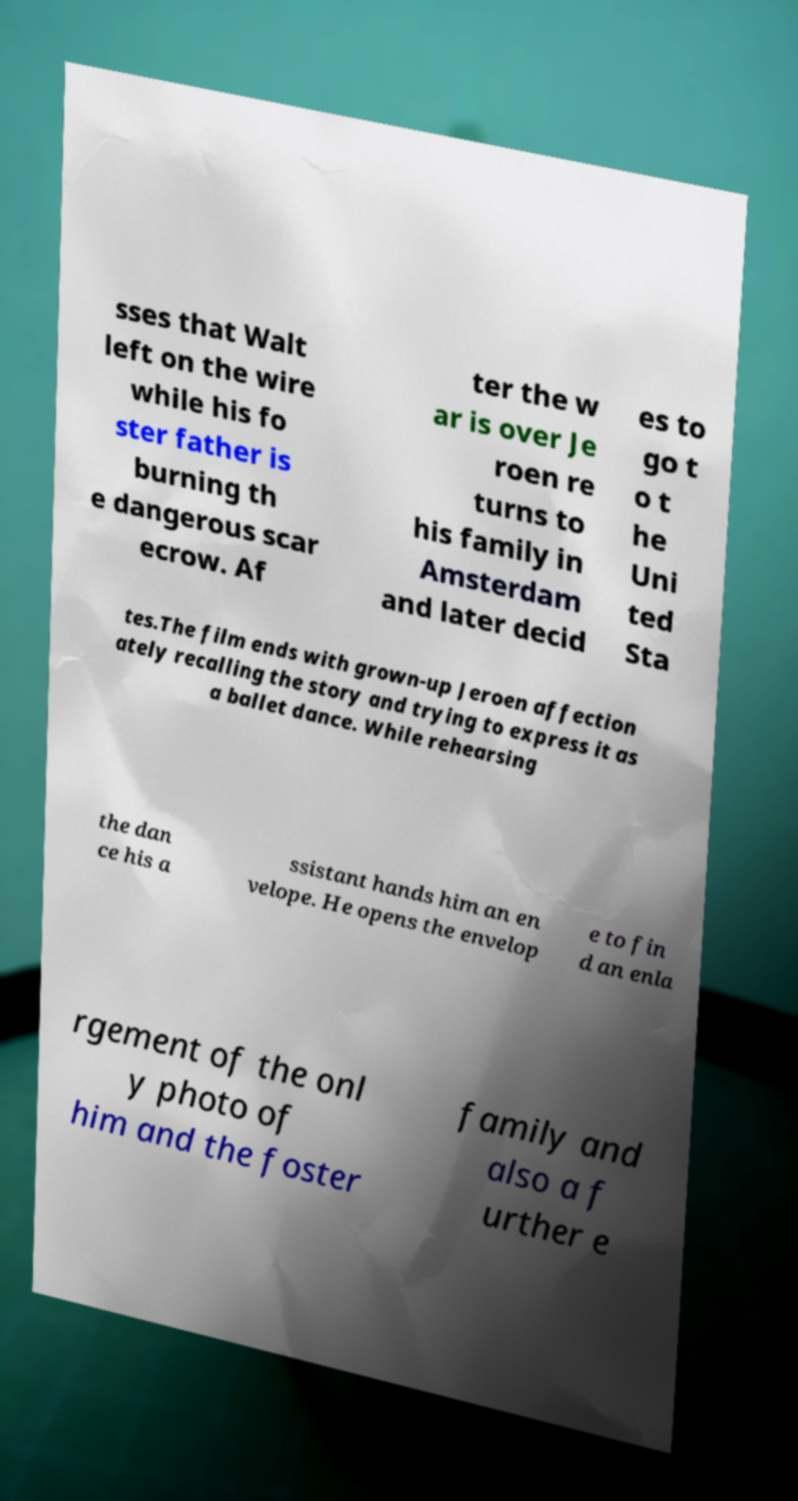Please identify and transcribe the text found in this image. sses that Walt left on the wire while his fo ster father is burning th e dangerous scar ecrow. Af ter the w ar is over Je roen re turns to his family in Amsterdam and later decid es to go t o t he Uni ted Sta tes.The film ends with grown-up Jeroen affection ately recalling the story and trying to express it as a ballet dance. While rehearsing the dan ce his a ssistant hands him an en velope. He opens the envelop e to fin d an enla rgement of the onl y photo of him and the foster family and also a f urther e 